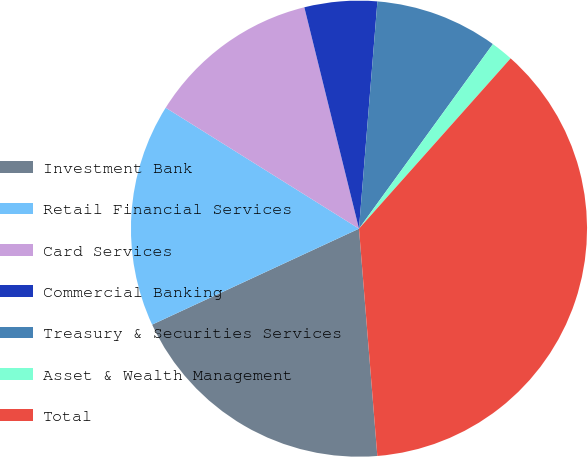<chart> <loc_0><loc_0><loc_500><loc_500><pie_chart><fcel>Investment Bank<fcel>Retail Financial Services<fcel>Card Services<fcel>Commercial Banking<fcel>Treasury & Securities Services<fcel>Asset & Wealth Management<fcel>Total<nl><fcel>19.37%<fcel>15.81%<fcel>12.25%<fcel>5.14%<fcel>8.7%<fcel>1.59%<fcel>37.14%<nl></chart> 